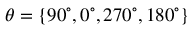<formula> <loc_0><loc_0><loc_500><loc_500>\theta = \{ 9 0 ^ { \circ } , 0 ^ { \circ } , 2 7 0 ^ { \circ } , 1 8 0 ^ { \circ } \}</formula> 